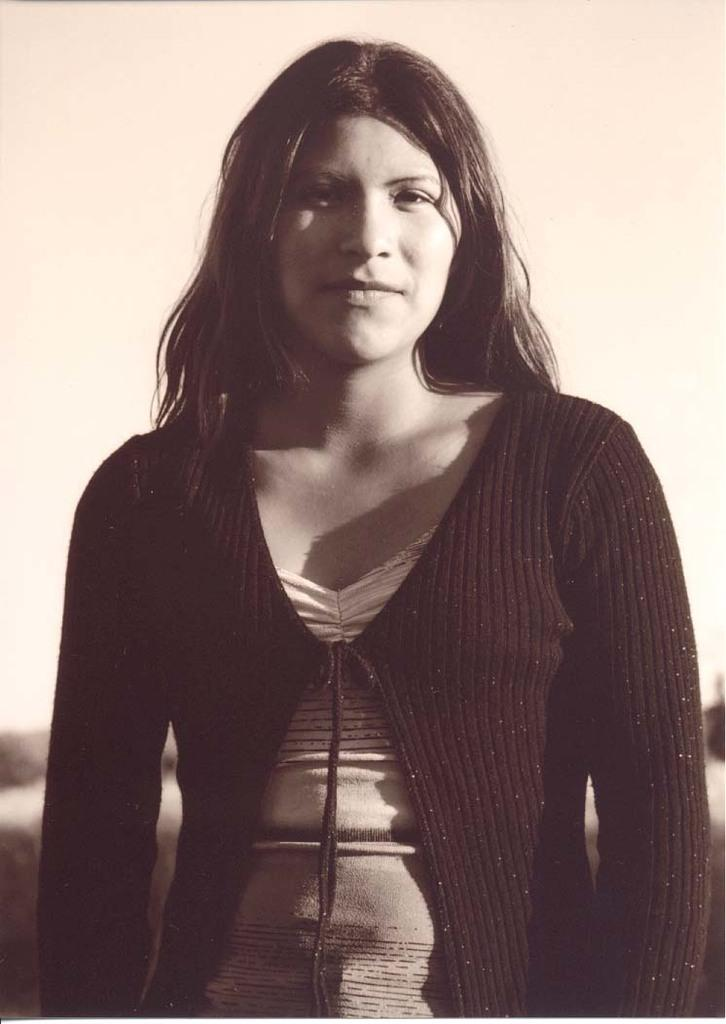What is the color scheme of the image? The image is black and white. Who is present in the image? There is a woman in the image. What is the woman doing in the image? The woman is watching and smiling. Can you describe the background of the image? The background of the image is blurred. What type of plants can be seen growing in the background of the image? There are no plants visible in the image, as the background is blurred and only the woman is in focus. 